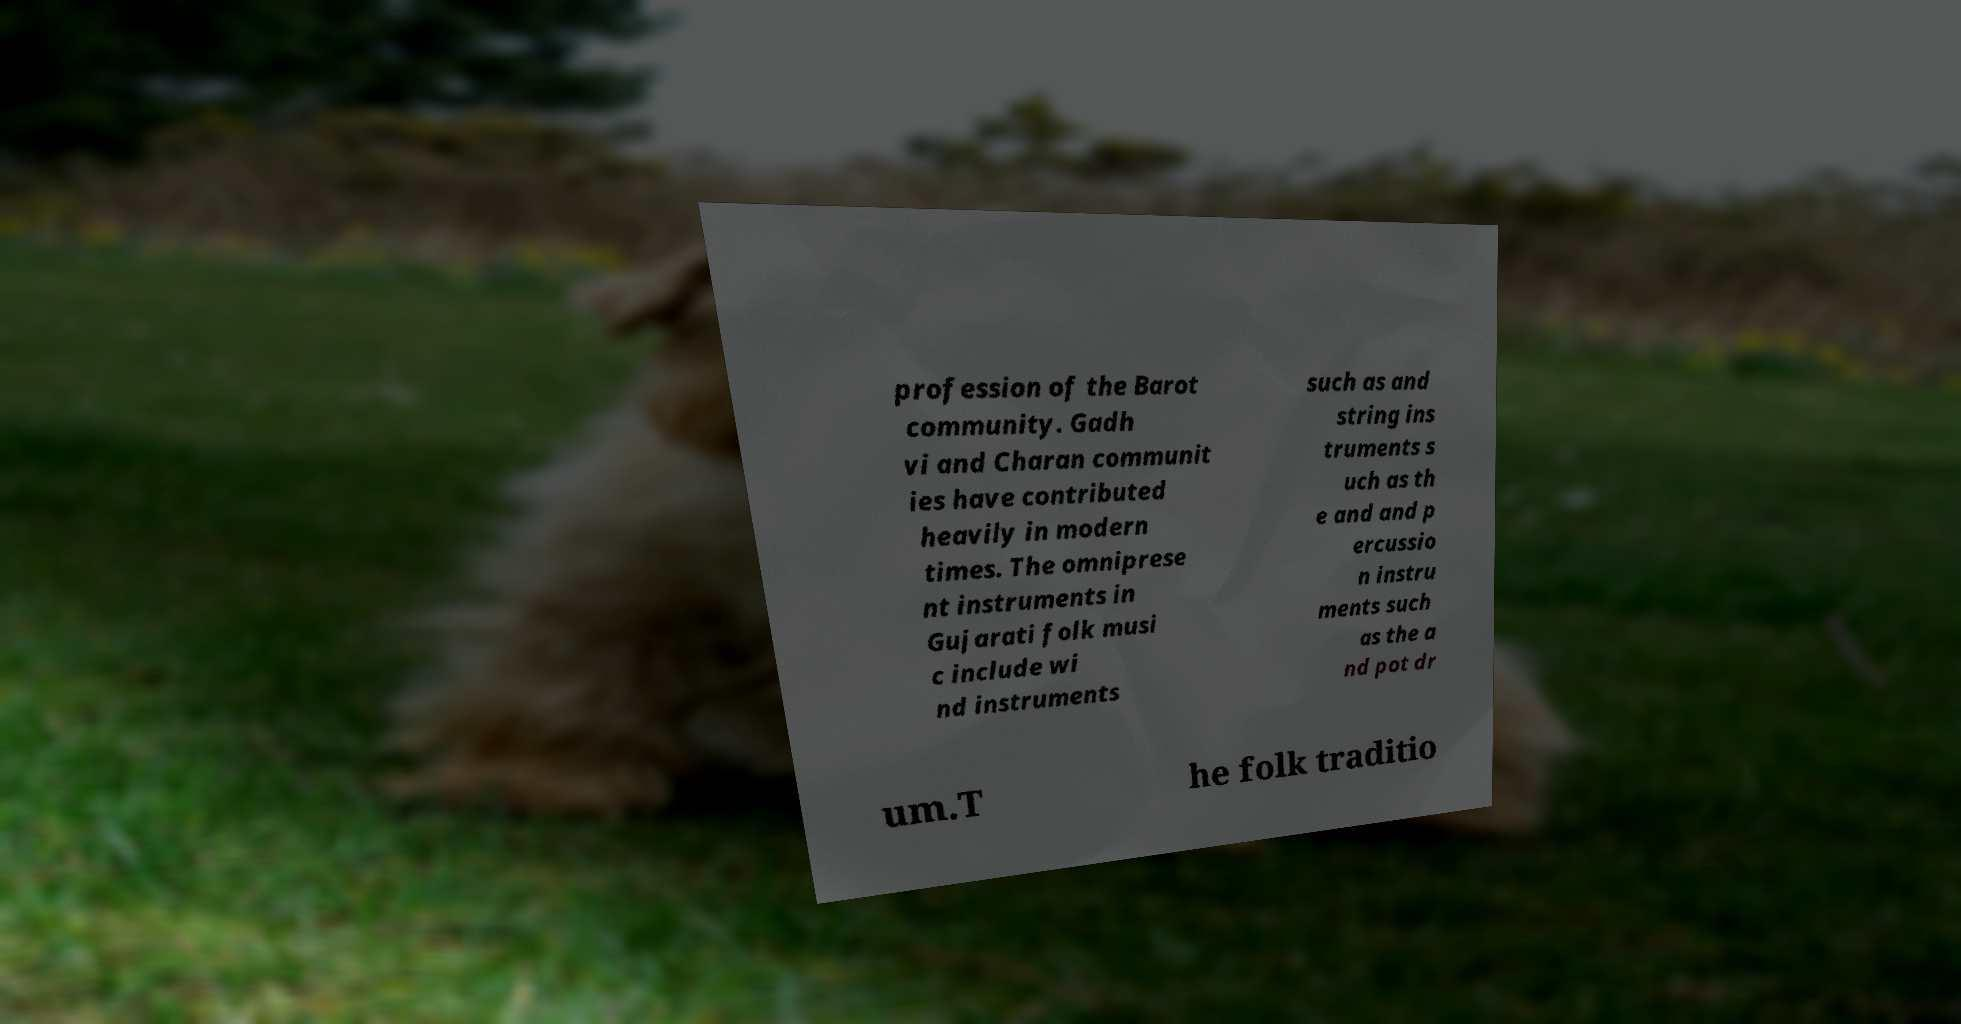I need the written content from this picture converted into text. Can you do that? profession of the Barot community. Gadh vi and Charan communit ies have contributed heavily in modern times. The omniprese nt instruments in Gujarati folk musi c include wi nd instruments such as and string ins truments s uch as th e and and p ercussio n instru ments such as the a nd pot dr um.T he folk traditio 